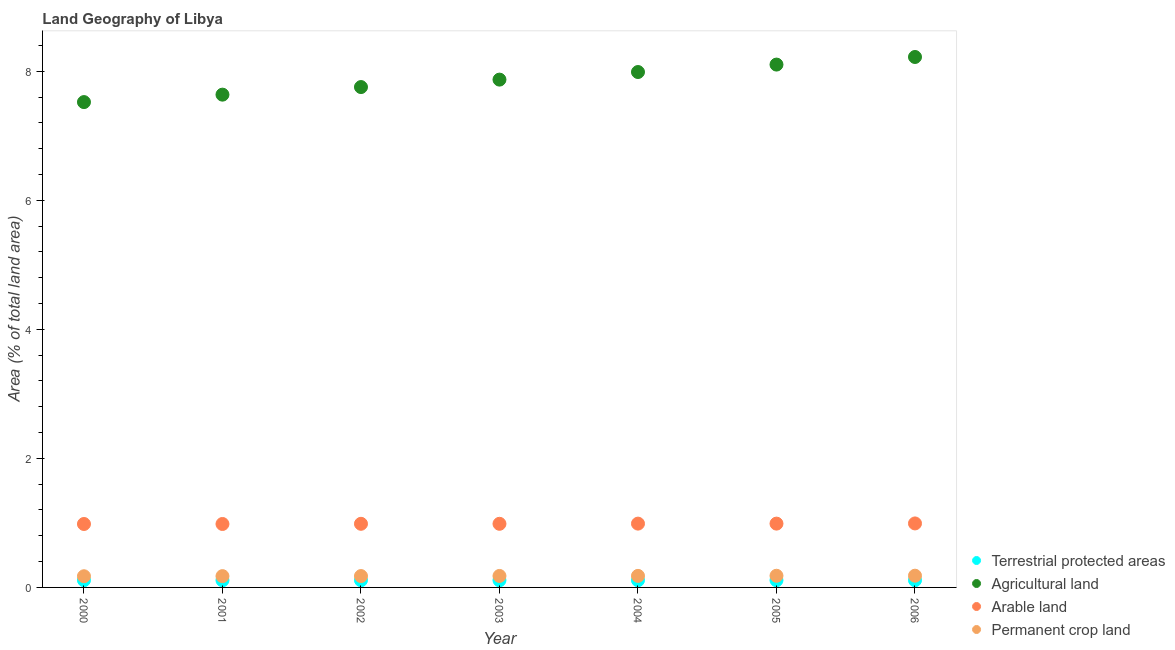What is the percentage of area under permanent crop land in 2001?
Your answer should be very brief. 0.18. Across all years, what is the maximum percentage of land under terrestrial protection?
Provide a short and direct response. 0.11. Across all years, what is the minimum percentage of area under arable land?
Your answer should be very brief. 0.98. In which year was the percentage of area under permanent crop land maximum?
Offer a very short reply. 2006. What is the total percentage of area under permanent crop land in the graph?
Provide a succinct answer. 1.24. What is the difference between the percentage of area under arable land in 2001 and that in 2003?
Your answer should be compact. -0. What is the difference between the percentage of area under permanent crop land in 2003 and the percentage of area under arable land in 2006?
Your answer should be compact. -0.81. What is the average percentage of area under arable land per year?
Your answer should be very brief. 0.99. In the year 2000, what is the difference between the percentage of area under agricultural land and percentage of area under permanent crop land?
Offer a terse response. 7.35. What is the ratio of the percentage of area under permanent crop land in 2001 to that in 2002?
Your response must be concise. 0.99. What is the difference between the highest and the second highest percentage of area under permanent crop land?
Give a very brief answer. 0. What is the difference between the highest and the lowest percentage of area under arable land?
Give a very brief answer. 0.01. In how many years, is the percentage of area under permanent crop land greater than the average percentage of area under permanent crop land taken over all years?
Your answer should be compact. 4. Is the sum of the percentage of area under permanent crop land in 2003 and 2006 greater than the maximum percentage of land under terrestrial protection across all years?
Your response must be concise. Yes. Does the percentage of area under arable land monotonically increase over the years?
Offer a terse response. No. Is the percentage of area under arable land strictly greater than the percentage of area under permanent crop land over the years?
Offer a terse response. Yes. Is the percentage of area under agricultural land strictly less than the percentage of land under terrestrial protection over the years?
Keep it short and to the point. No. How many dotlines are there?
Give a very brief answer. 4. Does the graph contain any zero values?
Give a very brief answer. No. Where does the legend appear in the graph?
Provide a short and direct response. Bottom right. How many legend labels are there?
Provide a succinct answer. 4. What is the title of the graph?
Ensure brevity in your answer.  Land Geography of Libya. Does "United States" appear as one of the legend labels in the graph?
Your answer should be compact. No. What is the label or title of the X-axis?
Make the answer very short. Year. What is the label or title of the Y-axis?
Offer a very short reply. Area (% of total land area). What is the Area (% of total land area) in Terrestrial protected areas in 2000?
Ensure brevity in your answer.  0.11. What is the Area (% of total land area) in Agricultural land in 2000?
Offer a very short reply. 7.52. What is the Area (% of total land area) in Arable land in 2000?
Keep it short and to the point. 0.98. What is the Area (% of total land area) of Permanent crop land in 2000?
Offer a very short reply. 0.17. What is the Area (% of total land area) of Terrestrial protected areas in 2001?
Give a very brief answer. 0.11. What is the Area (% of total land area) of Agricultural land in 2001?
Your answer should be very brief. 7.64. What is the Area (% of total land area) of Arable land in 2001?
Your response must be concise. 0.98. What is the Area (% of total land area) of Permanent crop land in 2001?
Provide a short and direct response. 0.18. What is the Area (% of total land area) in Terrestrial protected areas in 2002?
Provide a short and direct response. 0.11. What is the Area (% of total land area) in Agricultural land in 2002?
Your answer should be compact. 7.75. What is the Area (% of total land area) of Arable land in 2002?
Keep it short and to the point. 0.99. What is the Area (% of total land area) of Permanent crop land in 2002?
Provide a succinct answer. 0.18. What is the Area (% of total land area) in Terrestrial protected areas in 2003?
Keep it short and to the point. 0.11. What is the Area (% of total land area) of Agricultural land in 2003?
Make the answer very short. 7.87. What is the Area (% of total land area) in Arable land in 2003?
Provide a short and direct response. 0.99. What is the Area (% of total land area) in Permanent crop land in 2003?
Offer a very short reply. 0.18. What is the Area (% of total land area) of Terrestrial protected areas in 2004?
Ensure brevity in your answer.  0.11. What is the Area (% of total land area) of Agricultural land in 2004?
Ensure brevity in your answer.  7.99. What is the Area (% of total land area) in Arable land in 2004?
Provide a succinct answer. 0.99. What is the Area (% of total land area) in Permanent crop land in 2004?
Provide a short and direct response. 0.18. What is the Area (% of total land area) of Terrestrial protected areas in 2005?
Offer a very short reply. 0.11. What is the Area (% of total land area) in Agricultural land in 2005?
Provide a succinct answer. 8.1. What is the Area (% of total land area) of Arable land in 2005?
Your answer should be compact. 0.99. What is the Area (% of total land area) of Permanent crop land in 2005?
Offer a very short reply. 0.18. What is the Area (% of total land area) of Terrestrial protected areas in 2006?
Your answer should be very brief. 0.11. What is the Area (% of total land area) in Agricultural land in 2006?
Make the answer very short. 8.22. What is the Area (% of total land area) of Arable land in 2006?
Provide a short and direct response. 0.99. What is the Area (% of total land area) of Permanent crop land in 2006?
Keep it short and to the point. 0.18. Across all years, what is the maximum Area (% of total land area) of Terrestrial protected areas?
Your response must be concise. 0.11. Across all years, what is the maximum Area (% of total land area) in Agricultural land?
Your response must be concise. 8.22. Across all years, what is the maximum Area (% of total land area) in Arable land?
Provide a succinct answer. 0.99. Across all years, what is the maximum Area (% of total land area) of Permanent crop land?
Offer a very short reply. 0.18. Across all years, what is the minimum Area (% of total land area) of Terrestrial protected areas?
Your answer should be compact. 0.11. Across all years, what is the minimum Area (% of total land area) of Agricultural land?
Provide a succinct answer. 7.52. Across all years, what is the minimum Area (% of total land area) in Arable land?
Keep it short and to the point. 0.98. Across all years, what is the minimum Area (% of total land area) in Permanent crop land?
Offer a terse response. 0.17. What is the total Area (% of total land area) of Terrestrial protected areas in the graph?
Ensure brevity in your answer.  0.78. What is the total Area (% of total land area) of Agricultural land in the graph?
Your answer should be compact. 55.1. What is the total Area (% of total land area) in Arable land in the graph?
Offer a terse response. 6.91. What is the total Area (% of total land area) of Permanent crop land in the graph?
Provide a short and direct response. 1.24. What is the difference between the Area (% of total land area) in Terrestrial protected areas in 2000 and that in 2001?
Make the answer very short. 0. What is the difference between the Area (% of total land area) of Agricultural land in 2000 and that in 2001?
Keep it short and to the point. -0.12. What is the difference between the Area (% of total land area) of Permanent crop land in 2000 and that in 2001?
Your answer should be very brief. -0. What is the difference between the Area (% of total land area) of Terrestrial protected areas in 2000 and that in 2002?
Your answer should be very brief. 0. What is the difference between the Area (% of total land area) of Agricultural land in 2000 and that in 2002?
Keep it short and to the point. -0.23. What is the difference between the Area (% of total land area) of Arable land in 2000 and that in 2002?
Provide a succinct answer. -0. What is the difference between the Area (% of total land area) in Permanent crop land in 2000 and that in 2002?
Your answer should be very brief. -0. What is the difference between the Area (% of total land area) in Agricultural land in 2000 and that in 2003?
Your answer should be compact. -0.35. What is the difference between the Area (% of total land area) of Arable land in 2000 and that in 2003?
Give a very brief answer. -0. What is the difference between the Area (% of total land area) of Permanent crop land in 2000 and that in 2003?
Offer a very short reply. -0. What is the difference between the Area (% of total land area) of Agricultural land in 2000 and that in 2004?
Offer a very short reply. -0.47. What is the difference between the Area (% of total land area) of Arable land in 2000 and that in 2004?
Provide a succinct answer. -0.01. What is the difference between the Area (% of total land area) of Permanent crop land in 2000 and that in 2004?
Keep it short and to the point. -0.01. What is the difference between the Area (% of total land area) of Terrestrial protected areas in 2000 and that in 2005?
Keep it short and to the point. 0. What is the difference between the Area (% of total land area) of Agricultural land in 2000 and that in 2005?
Your response must be concise. -0.58. What is the difference between the Area (% of total land area) in Arable land in 2000 and that in 2005?
Your response must be concise. -0.01. What is the difference between the Area (% of total land area) in Permanent crop land in 2000 and that in 2005?
Offer a very short reply. -0.01. What is the difference between the Area (% of total land area) of Terrestrial protected areas in 2000 and that in 2006?
Your answer should be very brief. 0. What is the difference between the Area (% of total land area) in Agricultural land in 2000 and that in 2006?
Provide a succinct answer. -0.7. What is the difference between the Area (% of total land area) of Arable land in 2000 and that in 2006?
Your response must be concise. -0.01. What is the difference between the Area (% of total land area) of Permanent crop land in 2000 and that in 2006?
Your answer should be very brief. -0.01. What is the difference between the Area (% of total land area) of Terrestrial protected areas in 2001 and that in 2002?
Keep it short and to the point. -0. What is the difference between the Area (% of total land area) of Agricultural land in 2001 and that in 2002?
Offer a very short reply. -0.12. What is the difference between the Area (% of total land area) of Arable land in 2001 and that in 2002?
Your answer should be compact. -0. What is the difference between the Area (% of total land area) of Permanent crop land in 2001 and that in 2002?
Offer a very short reply. -0. What is the difference between the Area (% of total land area) in Terrestrial protected areas in 2001 and that in 2003?
Ensure brevity in your answer.  -0. What is the difference between the Area (% of total land area) of Agricultural land in 2001 and that in 2003?
Your answer should be very brief. -0.23. What is the difference between the Area (% of total land area) in Arable land in 2001 and that in 2003?
Keep it short and to the point. -0. What is the difference between the Area (% of total land area) of Permanent crop land in 2001 and that in 2003?
Your answer should be compact. -0. What is the difference between the Area (% of total land area) in Terrestrial protected areas in 2001 and that in 2004?
Provide a succinct answer. -0. What is the difference between the Area (% of total land area) of Agricultural land in 2001 and that in 2004?
Provide a short and direct response. -0.35. What is the difference between the Area (% of total land area) of Arable land in 2001 and that in 2004?
Ensure brevity in your answer.  -0.01. What is the difference between the Area (% of total land area) of Permanent crop land in 2001 and that in 2004?
Keep it short and to the point. -0. What is the difference between the Area (% of total land area) in Terrestrial protected areas in 2001 and that in 2005?
Keep it short and to the point. -0. What is the difference between the Area (% of total land area) in Agricultural land in 2001 and that in 2005?
Ensure brevity in your answer.  -0.47. What is the difference between the Area (% of total land area) of Arable land in 2001 and that in 2005?
Offer a very short reply. -0.01. What is the difference between the Area (% of total land area) of Permanent crop land in 2001 and that in 2005?
Your response must be concise. -0.01. What is the difference between the Area (% of total land area) in Terrestrial protected areas in 2001 and that in 2006?
Ensure brevity in your answer.  -0. What is the difference between the Area (% of total land area) of Agricultural land in 2001 and that in 2006?
Offer a terse response. -0.58. What is the difference between the Area (% of total land area) in Arable land in 2001 and that in 2006?
Offer a terse response. -0.01. What is the difference between the Area (% of total land area) of Permanent crop land in 2001 and that in 2006?
Make the answer very short. -0.01. What is the difference between the Area (% of total land area) in Terrestrial protected areas in 2002 and that in 2003?
Offer a terse response. 0. What is the difference between the Area (% of total land area) of Agricultural land in 2002 and that in 2003?
Provide a short and direct response. -0.12. What is the difference between the Area (% of total land area) of Arable land in 2002 and that in 2003?
Provide a short and direct response. 0. What is the difference between the Area (% of total land area) of Permanent crop land in 2002 and that in 2003?
Ensure brevity in your answer.  -0. What is the difference between the Area (% of total land area) in Terrestrial protected areas in 2002 and that in 2004?
Ensure brevity in your answer.  0. What is the difference between the Area (% of total land area) in Agricultural land in 2002 and that in 2004?
Offer a terse response. -0.23. What is the difference between the Area (% of total land area) in Arable land in 2002 and that in 2004?
Provide a succinct answer. -0. What is the difference between the Area (% of total land area) of Permanent crop land in 2002 and that in 2004?
Ensure brevity in your answer.  -0. What is the difference between the Area (% of total land area) in Agricultural land in 2002 and that in 2005?
Provide a short and direct response. -0.35. What is the difference between the Area (% of total land area) of Arable land in 2002 and that in 2005?
Offer a very short reply. -0. What is the difference between the Area (% of total land area) of Permanent crop land in 2002 and that in 2005?
Provide a succinct answer. -0. What is the difference between the Area (% of total land area) in Agricultural land in 2002 and that in 2006?
Your answer should be compact. -0.47. What is the difference between the Area (% of total land area) of Arable land in 2002 and that in 2006?
Keep it short and to the point. -0.01. What is the difference between the Area (% of total land area) in Permanent crop land in 2002 and that in 2006?
Your answer should be very brief. -0.01. What is the difference between the Area (% of total land area) of Terrestrial protected areas in 2003 and that in 2004?
Your answer should be very brief. 0. What is the difference between the Area (% of total land area) in Agricultural land in 2003 and that in 2004?
Make the answer very short. -0.12. What is the difference between the Area (% of total land area) in Arable land in 2003 and that in 2004?
Ensure brevity in your answer.  -0. What is the difference between the Area (% of total land area) in Permanent crop land in 2003 and that in 2004?
Ensure brevity in your answer.  -0. What is the difference between the Area (% of total land area) in Agricultural land in 2003 and that in 2005?
Provide a short and direct response. -0.23. What is the difference between the Area (% of total land area) in Arable land in 2003 and that in 2005?
Ensure brevity in your answer.  -0. What is the difference between the Area (% of total land area) in Permanent crop land in 2003 and that in 2005?
Offer a very short reply. -0. What is the difference between the Area (% of total land area) in Terrestrial protected areas in 2003 and that in 2006?
Offer a very short reply. 0. What is the difference between the Area (% of total land area) of Agricultural land in 2003 and that in 2006?
Provide a short and direct response. -0.35. What is the difference between the Area (% of total land area) of Arable land in 2003 and that in 2006?
Provide a short and direct response. -0.01. What is the difference between the Area (% of total land area) of Permanent crop land in 2003 and that in 2006?
Offer a very short reply. -0. What is the difference between the Area (% of total land area) in Terrestrial protected areas in 2004 and that in 2005?
Provide a succinct answer. 0. What is the difference between the Area (% of total land area) of Agricultural land in 2004 and that in 2005?
Provide a short and direct response. -0.12. What is the difference between the Area (% of total land area) in Permanent crop land in 2004 and that in 2005?
Provide a short and direct response. -0. What is the difference between the Area (% of total land area) in Terrestrial protected areas in 2004 and that in 2006?
Offer a very short reply. 0. What is the difference between the Area (% of total land area) in Agricultural land in 2004 and that in 2006?
Keep it short and to the point. -0.23. What is the difference between the Area (% of total land area) of Arable land in 2004 and that in 2006?
Keep it short and to the point. -0. What is the difference between the Area (% of total land area) in Permanent crop land in 2004 and that in 2006?
Provide a succinct answer. -0. What is the difference between the Area (% of total land area) of Terrestrial protected areas in 2005 and that in 2006?
Give a very brief answer. 0. What is the difference between the Area (% of total land area) of Agricultural land in 2005 and that in 2006?
Keep it short and to the point. -0.12. What is the difference between the Area (% of total land area) of Arable land in 2005 and that in 2006?
Your response must be concise. -0. What is the difference between the Area (% of total land area) in Permanent crop land in 2005 and that in 2006?
Your answer should be compact. -0. What is the difference between the Area (% of total land area) in Terrestrial protected areas in 2000 and the Area (% of total land area) in Agricultural land in 2001?
Your response must be concise. -7.53. What is the difference between the Area (% of total land area) in Terrestrial protected areas in 2000 and the Area (% of total land area) in Arable land in 2001?
Offer a very short reply. -0.87. What is the difference between the Area (% of total land area) of Terrestrial protected areas in 2000 and the Area (% of total land area) of Permanent crop land in 2001?
Provide a short and direct response. -0.06. What is the difference between the Area (% of total land area) in Agricultural land in 2000 and the Area (% of total land area) in Arable land in 2001?
Your answer should be compact. 6.54. What is the difference between the Area (% of total land area) of Agricultural land in 2000 and the Area (% of total land area) of Permanent crop land in 2001?
Provide a short and direct response. 7.35. What is the difference between the Area (% of total land area) of Arable land in 2000 and the Area (% of total land area) of Permanent crop land in 2001?
Offer a terse response. 0.81. What is the difference between the Area (% of total land area) in Terrestrial protected areas in 2000 and the Area (% of total land area) in Agricultural land in 2002?
Give a very brief answer. -7.64. What is the difference between the Area (% of total land area) in Terrestrial protected areas in 2000 and the Area (% of total land area) in Arable land in 2002?
Provide a short and direct response. -0.87. What is the difference between the Area (% of total land area) of Terrestrial protected areas in 2000 and the Area (% of total land area) of Permanent crop land in 2002?
Give a very brief answer. -0.06. What is the difference between the Area (% of total land area) of Agricultural land in 2000 and the Area (% of total land area) of Arable land in 2002?
Your answer should be compact. 6.54. What is the difference between the Area (% of total land area) of Agricultural land in 2000 and the Area (% of total land area) of Permanent crop land in 2002?
Your response must be concise. 7.35. What is the difference between the Area (% of total land area) in Arable land in 2000 and the Area (% of total land area) in Permanent crop land in 2002?
Keep it short and to the point. 0.81. What is the difference between the Area (% of total land area) of Terrestrial protected areas in 2000 and the Area (% of total land area) of Agricultural land in 2003?
Make the answer very short. -7.76. What is the difference between the Area (% of total land area) of Terrestrial protected areas in 2000 and the Area (% of total land area) of Arable land in 2003?
Offer a very short reply. -0.87. What is the difference between the Area (% of total land area) of Terrestrial protected areas in 2000 and the Area (% of total land area) of Permanent crop land in 2003?
Ensure brevity in your answer.  -0.07. What is the difference between the Area (% of total land area) of Agricultural land in 2000 and the Area (% of total land area) of Arable land in 2003?
Make the answer very short. 6.54. What is the difference between the Area (% of total land area) in Agricultural land in 2000 and the Area (% of total land area) in Permanent crop land in 2003?
Offer a very short reply. 7.34. What is the difference between the Area (% of total land area) in Arable land in 2000 and the Area (% of total land area) in Permanent crop land in 2003?
Keep it short and to the point. 0.81. What is the difference between the Area (% of total land area) in Terrestrial protected areas in 2000 and the Area (% of total land area) in Agricultural land in 2004?
Give a very brief answer. -7.88. What is the difference between the Area (% of total land area) in Terrestrial protected areas in 2000 and the Area (% of total land area) in Arable land in 2004?
Your answer should be very brief. -0.88. What is the difference between the Area (% of total land area) in Terrestrial protected areas in 2000 and the Area (% of total land area) in Permanent crop land in 2004?
Offer a very short reply. -0.07. What is the difference between the Area (% of total land area) in Agricultural land in 2000 and the Area (% of total land area) in Arable land in 2004?
Ensure brevity in your answer.  6.53. What is the difference between the Area (% of total land area) of Agricultural land in 2000 and the Area (% of total land area) of Permanent crop land in 2004?
Offer a very short reply. 7.34. What is the difference between the Area (% of total land area) in Arable land in 2000 and the Area (% of total land area) in Permanent crop land in 2004?
Your answer should be compact. 0.8. What is the difference between the Area (% of total land area) of Terrestrial protected areas in 2000 and the Area (% of total land area) of Agricultural land in 2005?
Keep it short and to the point. -7.99. What is the difference between the Area (% of total land area) of Terrestrial protected areas in 2000 and the Area (% of total land area) of Arable land in 2005?
Make the answer very short. -0.88. What is the difference between the Area (% of total land area) in Terrestrial protected areas in 2000 and the Area (% of total land area) in Permanent crop land in 2005?
Keep it short and to the point. -0.07. What is the difference between the Area (% of total land area) in Agricultural land in 2000 and the Area (% of total land area) in Arable land in 2005?
Your response must be concise. 6.53. What is the difference between the Area (% of total land area) of Agricultural land in 2000 and the Area (% of total land area) of Permanent crop land in 2005?
Your answer should be very brief. 7.34. What is the difference between the Area (% of total land area) of Arable land in 2000 and the Area (% of total land area) of Permanent crop land in 2005?
Ensure brevity in your answer.  0.8. What is the difference between the Area (% of total land area) in Terrestrial protected areas in 2000 and the Area (% of total land area) in Agricultural land in 2006?
Make the answer very short. -8.11. What is the difference between the Area (% of total land area) in Terrestrial protected areas in 2000 and the Area (% of total land area) in Arable land in 2006?
Ensure brevity in your answer.  -0.88. What is the difference between the Area (% of total land area) in Terrestrial protected areas in 2000 and the Area (% of total land area) in Permanent crop land in 2006?
Your answer should be very brief. -0.07. What is the difference between the Area (% of total land area) of Agricultural land in 2000 and the Area (% of total land area) of Arable land in 2006?
Provide a succinct answer. 6.53. What is the difference between the Area (% of total land area) in Agricultural land in 2000 and the Area (% of total land area) in Permanent crop land in 2006?
Your answer should be compact. 7.34. What is the difference between the Area (% of total land area) in Arable land in 2000 and the Area (% of total land area) in Permanent crop land in 2006?
Offer a very short reply. 0.8. What is the difference between the Area (% of total land area) in Terrestrial protected areas in 2001 and the Area (% of total land area) in Agricultural land in 2002?
Ensure brevity in your answer.  -7.64. What is the difference between the Area (% of total land area) in Terrestrial protected areas in 2001 and the Area (% of total land area) in Arable land in 2002?
Offer a very short reply. -0.88. What is the difference between the Area (% of total land area) in Terrestrial protected areas in 2001 and the Area (% of total land area) in Permanent crop land in 2002?
Make the answer very short. -0.07. What is the difference between the Area (% of total land area) in Agricultural land in 2001 and the Area (% of total land area) in Arable land in 2002?
Keep it short and to the point. 6.65. What is the difference between the Area (% of total land area) in Agricultural land in 2001 and the Area (% of total land area) in Permanent crop land in 2002?
Your answer should be compact. 7.46. What is the difference between the Area (% of total land area) of Arable land in 2001 and the Area (% of total land area) of Permanent crop land in 2002?
Offer a very short reply. 0.81. What is the difference between the Area (% of total land area) in Terrestrial protected areas in 2001 and the Area (% of total land area) in Agricultural land in 2003?
Keep it short and to the point. -7.76. What is the difference between the Area (% of total land area) in Terrestrial protected areas in 2001 and the Area (% of total land area) in Arable land in 2003?
Your answer should be compact. -0.88. What is the difference between the Area (% of total land area) of Terrestrial protected areas in 2001 and the Area (% of total land area) of Permanent crop land in 2003?
Give a very brief answer. -0.07. What is the difference between the Area (% of total land area) in Agricultural land in 2001 and the Area (% of total land area) in Arable land in 2003?
Your response must be concise. 6.65. What is the difference between the Area (% of total land area) of Agricultural land in 2001 and the Area (% of total land area) of Permanent crop land in 2003?
Your answer should be very brief. 7.46. What is the difference between the Area (% of total land area) in Arable land in 2001 and the Area (% of total land area) in Permanent crop land in 2003?
Make the answer very short. 0.81. What is the difference between the Area (% of total land area) of Terrestrial protected areas in 2001 and the Area (% of total land area) of Agricultural land in 2004?
Your answer should be very brief. -7.88. What is the difference between the Area (% of total land area) of Terrestrial protected areas in 2001 and the Area (% of total land area) of Arable land in 2004?
Provide a short and direct response. -0.88. What is the difference between the Area (% of total land area) of Terrestrial protected areas in 2001 and the Area (% of total land area) of Permanent crop land in 2004?
Provide a short and direct response. -0.07. What is the difference between the Area (% of total land area) of Agricultural land in 2001 and the Area (% of total land area) of Arable land in 2004?
Make the answer very short. 6.65. What is the difference between the Area (% of total land area) in Agricultural land in 2001 and the Area (% of total land area) in Permanent crop land in 2004?
Make the answer very short. 7.46. What is the difference between the Area (% of total land area) in Arable land in 2001 and the Area (% of total land area) in Permanent crop land in 2004?
Give a very brief answer. 0.8. What is the difference between the Area (% of total land area) of Terrestrial protected areas in 2001 and the Area (% of total land area) of Agricultural land in 2005?
Offer a terse response. -7.99. What is the difference between the Area (% of total land area) in Terrestrial protected areas in 2001 and the Area (% of total land area) in Arable land in 2005?
Your answer should be very brief. -0.88. What is the difference between the Area (% of total land area) in Terrestrial protected areas in 2001 and the Area (% of total land area) in Permanent crop land in 2005?
Provide a succinct answer. -0.07. What is the difference between the Area (% of total land area) in Agricultural land in 2001 and the Area (% of total land area) in Arable land in 2005?
Your answer should be compact. 6.65. What is the difference between the Area (% of total land area) in Agricultural land in 2001 and the Area (% of total land area) in Permanent crop land in 2005?
Your answer should be very brief. 7.46. What is the difference between the Area (% of total land area) of Arable land in 2001 and the Area (% of total land area) of Permanent crop land in 2005?
Your response must be concise. 0.8. What is the difference between the Area (% of total land area) of Terrestrial protected areas in 2001 and the Area (% of total land area) of Agricultural land in 2006?
Your answer should be compact. -8.11. What is the difference between the Area (% of total land area) in Terrestrial protected areas in 2001 and the Area (% of total land area) in Arable land in 2006?
Offer a very short reply. -0.88. What is the difference between the Area (% of total land area) in Terrestrial protected areas in 2001 and the Area (% of total land area) in Permanent crop land in 2006?
Provide a succinct answer. -0.07. What is the difference between the Area (% of total land area) of Agricultural land in 2001 and the Area (% of total land area) of Arable land in 2006?
Offer a very short reply. 6.65. What is the difference between the Area (% of total land area) in Agricultural land in 2001 and the Area (% of total land area) in Permanent crop land in 2006?
Your answer should be compact. 7.46. What is the difference between the Area (% of total land area) in Arable land in 2001 and the Area (% of total land area) in Permanent crop land in 2006?
Make the answer very short. 0.8. What is the difference between the Area (% of total land area) of Terrestrial protected areas in 2002 and the Area (% of total land area) of Agricultural land in 2003?
Your answer should be very brief. -7.76. What is the difference between the Area (% of total land area) of Terrestrial protected areas in 2002 and the Area (% of total land area) of Arable land in 2003?
Your answer should be very brief. -0.87. What is the difference between the Area (% of total land area) of Terrestrial protected areas in 2002 and the Area (% of total land area) of Permanent crop land in 2003?
Your answer should be very brief. -0.07. What is the difference between the Area (% of total land area) in Agricultural land in 2002 and the Area (% of total land area) in Arable land in 2003?
Keep it short and to the point. 6.77. What is the difference between the Area (% of total land area) in Agricultural land in 2002 and the Area (% of total land area) in Permanent crop land in 2003?
Keep it short and to the point. 7.58. What is the difference between the Area (% of total land area) of Arable land in 2002 and the Area (% of total land area) of Permanent crop land in 2003?
Your answer should be very brief. 0.81. What is the difference between the Area (% of total land area) in Terrestrial protected areas in 2002 and the Area (% of total land area) in Agricultural land in 2004?
Ensure brevity in your answer.  -7.88. What is the difference between the Area (% of total land area) of Terrestrial protected areas in 2002 and the Area (% of total land area) of Arable land in 2004?
Ensure brevity in your answer.  -0.88. What is the difference between the Area (% of total land area) in Terrestrial protected areas in 2002 and the Area (% of total land area) in Permanent crop land in 2004?
Your answer should be compact. -0.07. What is the difference between the Area (% of total land area) of Agricultural land in 2002 and the Area (% of total land area) of Arable land in 2004?
Your answer should be compact. 6.77. What is the difference between the Area (% of total land area) of Agricultural land in 2002 and the Area (% of total land area) of Permanent crop land in 2004?
Make the answer very short. 7.58. What is the difference between the Area (% of total land area) in Arable land in 2002 and the Area (% of total land area) in Permanent crop land in 2004?
Your answer should be compact. 0.81. What is the difference between the Area (% of total land area) of Terrestrial protected areas in 2002 and the Area (% of total land area) of Agricultural land in 2005?
Keep it short and to the point. -7.99. What is the difference between the Area (% of total land area) of Terrestrial protected areas in 2002 and the Area (% of total land area) of Arable land in 2005?
Ensure brevity in your answer.  -0.88. What is the difference between the Area (% of total land area) in Terrestrial protected areas in 2002 and the Area (% of total land area) in Permanent crop land in 2005?
Make the answer very short. -0.07. What is the difference between the Area (% of total land area) of Agricultural land in 2002 and the Area (% of total land area) of Arable land in 2005?
Ensure brevity in your answer.  6.77. What is the difference between the Area (% of total land area) in Agricultural land in 2002 and the Area (% of total land area) in Permanent crop land in 2005?
Give a very brief answer. 7.57. What is the difference between the Area (% of total land area) in Arable land in 2002 and the Area (% of total land area) in Permanent crop land in 2005?
Provide a short and direct response. 0.81. What is the difference between the Area (% of total land area) in Terrestrial protected areas in 2002 and the Area (% of total land area) in Agricultural land in 2006?
Your response must be concise. -8.11. What is the difference between the Area (% of total land area) in Terrestrial protected areas in 2002 and the Area (% of total land area) in Arable land in 2006?
Keep it short and to the point. -0.88. What is the difference between the Area (% of total land area) in Terrestrial protected areas in 2002 and the Area (% of total land area) in Permanent crop land in 2006?
Your response must be concise. -0.07. What is the difference between the Area (% of total land area) in Agricultural land in 2002 and the Area (% of total land area) in Arable land in 2006?
Make the answer very short. 6.76. What is the difference between the Area (% of total land area) in Agricultural land in 2002 and the Area (% of total land area) in Permanent crop land in 2006?
Your answer should be compact. 7.57. What is the difference between the Area (% of total land area) of Arable land in 2002 and the Area (% of total land area) of Permanent crop land in 2006?
Keep it short and to the point. 0.8. What is the difference between the Area (% of total land area) of Terrestrial protected areas in 2003 and the Area (% of total land area) of Agricultural land in 2004?
Provide a short and direct response. -7.88. What is the difference between the Area (% of total land area) of Terrestrial protected areas in 2003 and the Area (% of total land area) of Arable land in 2004?
Give a very brief answer. -0.88. What is the difference between the Area (% of total land area) in Terrestrial protected areas in 2003 and the Area (% of total land area) in Permanent crop land in 2004?
Provide a short and direct response. -0.07. What is the difference between the Area (% of total land area) in Agricultural land in 2003 and the Area (% of total land area) in Arable land in 2004?
Keep it short and to the point. 6.88. What is the difference between the Area (% of total land area) in Agricultural land in 2003 and the Area (% of total land area) in Permanent crop land in 2004?
Offer a very short reply. 7.69. What is the difference between the Area (% of total land area) in Arable land in 2003 and the Area (% of total land area) in Permanent crop land in 2004?
Make the answer very short. 0.81. What is the difference between the Area (% of total land area) of Terrestrial protected areas in 2003 and the Area (% of total land area) of Agricultural land in 2005?
Offer a terse response. -7.99. What is the difference between the Area (% of total land area) in Terrestrial protected areas in 2003 and the Area (% of total land area) in Arable land in 2005?
Give a very brief answer. -0.88. What is the difference between the Area (% of total land area) of Terrestrial protected areas in 2003 and the Area (% of total land area) of Permanent crop land in 2005?
Your answer should be compact. -0.07. What is the difference between the Area (% of total land area) in Agricultural land in 2003 and the Area (% of total land area) in Arable land in 2005?
Your answer should be compact. 6.88. What is the difference between the Area (% of total land area) in Agricultural land in 2003 and the Area (% of total land area) in Permanent crop land in 2005?
Offer a very short reply. 7.69. What is the difference between the Area (% of total land area) in Arable land in 2003 and the Area (% of total land area) in Permanent crop land in 2005?
Offer a terse response. 0.81. What is the difference between the Area (% of total land area) in Terrestrial protected areas in 2003 and the Area (% of total land area) in Agricultural land in 2006?
Give a very brief answer. -8.11. What is the difference between the Area (% of total land area) of Terrestrial protected areas in 2003 and the Area (% of total land area) of Arable land in 2006?
Offer a terse response. -0.88. What is the difference between the Area (% of total land area) in Terrestrial protected areas in 2003 and the Area (% of total land area) in Permanent crop land in 2006?
Your response must be concise. -0.07. What is the difference between the Area (% of total land area) in Agricultural land in 2003 and the Area (% of total land area) in Arable land in 2006?
Offer a terse response. 6.88. What is the difference between the Area (% of total land area) in Agricultural land in 2003 and the Area (% of total land area) in Permanent crop land in 2006?
Your answer should be very brief. 7.69. What is the difference between the Area (% of total land area) in Arable land in 2003 and the Area (% of total land area) in Permanent crop land in 2006?
Make the answer very short. 0.8. What is the difference between the Area (% of total land area) in Terrestrial protected areas in 2004 and the Area (% of total land area) in Agricultural land in 2005?
Your response must be concise. -7.99. What is the difference between the Area (% of total land area) of Terrestrial protected areas in 2004 and the Area (% of total land area) of Arable land in 2005?
Your answer should be compact. -0.88. What is the difference between the Area (% of total land area) of Terrestrial protected areas in 2004 and the Area (% of total land area) of Permanent crop land in 2005?
Give a very brief answer. -0.07. What is the difference between the Area (% of total land area) in Agricultural land in 2004 and the Area (% of total land area) in Arable land in 2005?
Keep it short and to the point. 7. What is the difference between the Area (% of total land area) of Agricultural land in 2004 and the Area (% of total land area) of Permanent crop land in 2005?
Provide a short and direct response. 7.81. What is the difference between the Area (% of total land area) of Arable land in 2004 and the Area (% of total land area) of Permanent crop land in 2005?
Your response must be concise. 0.81. What is the difference between the Area (% of total land area) in Terrestrial protected areas in 2004 and the Area (% of total land area) in Agricultural land in 2006?
Your answer should be very brief. -8.11. What is the difference between the Area (% of total land area) of Terrestrial protected areas in 2004 and the Area (% of total land area) of Arable land in 2006?
Your answer should be compact. -0.88. What is the difference between the Area (% of total land area) in Terrestrial protected areas in 2004 and the Area (% of total land area) in Permanent crop land in 2006?
Your answer should be compact. -0.07. What is the difference between the Area (% of total land area) of Agricultural land in 2004 and the Area (% of total land area) of Arable land in 2006?
Provide a short and direct response. 7. What is the difference between the Area (% of total land area) in Agricultural land in 2004 and the Area (% of total land area) in Permanent crop land in 2006?
Offer a very short reply. 7.81. What is the difference between the Area (% of total land area) in Arable land in 2004 and the Area (% of total land area) in Permanent crop land in 2006?
Provide a succinct answer. 0.81. What is the difference between the Area (% of total land area) of Terrestrial protected areas in 2005 and the Area (% of total land area) of Agricultural land in 2006?
Provide a short and direct response. -8.11. What is the difference between the Area (% of total land area) of Terrestrial protected areas in 2005 and the Area (% of total land area) of Arable land in 2006?
Offer a very short reply. -0.88. What is the difference between the Area (% of total land area) of Terrestrial protected areas in 2005 and the Area (% of total land area) of Permanent crop land in 2006?
Offer a very short reply. -0.07. What is the difference between the Area (% of total land area) of Agricultural land in 2005 and the Area (% of total land area) of Arable land in 2006?
Your answer should be very brief. 7.11. What is the difference between the Area (% of total land area) of Agricultural land in 2005 and the Area (% of total land area) of Permanent crop land in 2006?
Offer a terse response. 7.92. What is the difference between the Area (% of total land area) of Arable land in 2005 and the Area (% of total land area) of Permanent crop land in 2006?
Ensure brevity in your answer.  0.81. What is the average Area (% of total land area) of Terrestrial protected areas per year?
Your answer should be very brief. 0.11. What is the average Area (% of total land area) of Agricultural land per year?
Ensure brevity in your answer.  7.87. What is the average Area (% of total land area) of Arable land per year?
Ensure brevity in your answer.  0.99. What is the average Area (% of total land area) of Permanent crop land per year?
Your answer should be very brief. 0.18. In the year 2000, what is the difference between the Area (% of total land area) of Terrestrial protected areas and Area (% of total land area) of Agricultural land?
Your response must be concise. -7.41. In the year 2000, what is the difference between the Area (% of total land area) of Terrestrial protected areas and Area (% of total land area) of Arable land?
Ensure brevity in your answer.  -0.87. In the year 2000, what is the difference between the Area (% of total land area) in Terrestrial protected areas and Area (% of total land area) in Permanent crop land?
Offer a terse response. -0.06. In the year 2000, what is the difference between the Area (% of total land area) in Agricultural land and Area (% of total land area) in Arable land?
Keep it short and to the point. 6.54. In the year 2000, what is the difference between the Area (% of total land area) of Agricultural land and Area (% of total land area) of Permanent crop land?
Provide a succinct answer. 7.35. In the year 2000, what is the difference between the Area (% of total land area) of Arable land and Area (% of total land area) of Permanent crop land?
Ensure brevity in your answer.  0.81. In the year 2001, what is the difference between the Area (% of total land area) in Terrestrial protected areas and Area (% of total land area) in Agricultural land?
Keep it short and to the point. -7.53. In the year 2001, what is the difference between the Area (% of total land area) in Terrestrial protected areas and Area (% of total land area) in Arable land?
Your answer should be compact. -0.87. In the year 2001, what is the difference between the Area (% of total land area) of Terrestrial protected areas and Area (% of total land area) of Permanent crop land?
Provide a short and direct response. -0.06. In the year 2001, what is the difference between the Area (% of total land area) in Agricultural land and Area (% of total land area) in Arable land?
Keep it short and to the point. 6.65. In the year 2001, what is the difference between the Area (% of total land area) of Agricultural land and Area (% of total land area) of Permanent crop land?
Your answer should be very brief. 7.46. In the year 2001, what is the difference between the Area (% of total land area) in Arable land and Area (% of total land area) in Permanent crop land?
Your response must be concise. 0.81. In the year 2002, what is the difference between the Area (% of total land area) in Terrestrial protected areas and Area (% of total land area) in Agricultural land?
Make the answer very short. -7.64. In the year 2002, what is the difference between the Area (% of total land area) of Terrestrial protected areas and Area (% of total land area) of Arable land?
Ensure brevity in your answer.  -0.87. In the year 2002, what is the difference between the Area (% of total land area) in Terrestrial protected areas and Area (% of total land area) in Permanent crop land?
Your response must be concise. -0.07. In the year 2002, what is the difference between the Area (% of total land area) of Agricultural land and Area (% of total land area) of Arable land?
Provide a short and direct response. 6.77. In the year 2002, what is the difference between the Area (% of total land area) in Agricultural land and Area (% of total land area) in Permanent crop land?
Your answer should be very brief. 7.58. In the year 2002, what is the difference between the Area (% of total land area) of Arable land and Area (% of total land area) of Permanent crop land?
Your answer should be very brief. 0.81. In the year 2003, what is the difference between the Area (% of total land area) of Terrestrial protected areas and Area (% of total land area) of Agricultural land?
Offer a terse response. -7.76. In the year 2003, what is the difference between the Area (% of total land area) of Terrestrial protected areas and Area (% of total land area) of Arable land?
Your response must be concise. -0.87. In the year 2003, what is the difference between the Area (% of total land area) in Terrestrial protected areas and Area (% of total land area) in Permanent crop land?
Your answer should be very brief. -0.07. In the year 2003, what is the difference between the Area (% of total land area) of Agricultural land and Area (% of total land area) of Arable land?
Provide a succinct answer. 6.88. In the year 2003, what is the difference between the Area (% of total land area) of Agricultural land and Area (% of total land area) of Permanent crop land?
Your response must be concise. 7.69. In the year 2003, what is the difference between the Area (% of total land area) of Arable land and Area (% of total land area) of Permanent crop land?
Your answer should be very brief. 0.81. In the year 2004, what is the difference between the Area (% of total land area) of Terrestrial protected areas and Area (% of total land area) of Agricultural land?
Keep it short and to the point. -7.88. In the year 2004, what is the difference between the Area (% of total land area) in Terrestrial protected areas and Area (% of total land area) in Arable land?
Make the answer very short. -0.88. In the year 2004, what is the difference between the Area (% of total land area) in Terrestrial protected areas and Area (% of total land area) in Permanent crop land?
Your answer should be compact. -0.07. In the year 2004, what is the difference between the Area (% of total land area) in Agricultural land and Area (% of total land area) in Arable land?
Your answer should be very brief. 7. In the year 2004, what is the difference between the Area (% of total land area) of Agricultural land and Area (% of total land area) of Permanent crop land?
Offer a very short reply. 7.81. In the year 2004, what is the difference between the Area (% of total land area) in Arable land and Area (% of total land area) in Permanent crop land?
Offer a terse response. 0.81. In the year 2005, what is the difference between the Area (% of total land area) in Terrestrial protected areas and Area (% of total land area) in Agricultural land?
Provide a succinct answer. -7.99. In the year 2005, what is the difference between the Area (% of total land area) in Terrestrial protected areas and Area (% of total land area) in Arable land?
Provide a succinct answer. -0.88. In the year 2005, what is the difference between the Area (% of total land area) of Terrestrial protected areas and Area (% of total land area) of Permanent crop land?
Your answer should be compact. -0.07. In the year 2005, what is the difference between the Area (% of total land area) of Agricultural land and Area (% of total land area) of Arable land?
Ensure brevity in your answer.  7.11. In the year 2005, what is the difference between the Area (% of total land area) in Agricultural land and Area (% of total land area) in Permanent crop land?
Give a very brief answer. 7.92. In the year 2005, what is the difference between the Area (% of total land area) in Arable land and Area (% of total land area) in Permanent crop land?
Offer a very short reply. 0.81. In the year 2006, what is the difference between the Area (% of total land area) in Terrestrial protected areas and Area (% of total land area) in Agricultural land?
Your response must be concise. -8.11. In the year 2006, what is the difference between the Area (% of total land area) of Terrestrial protected areas and Area (% of total land area) of Arable land?
Your answer should be compact. -0.88. In the year 2006, what is the difference between the Area (% of total land area) in Terrestrial protected areas and Area (% of total land area) in Permanent crop land?
Give a very brief answer. -0.07. In the year 2006, what is the difference between the Area (% of total land area) of Agricultural land and Area (% of total land area) of Arable land?
Your response must be concise. 7.23. In the year 2006, what is the difference between the Area (% of total land area) in Agricultural land and Area (% of total land area) in Permanent crop land?
Offer a terse response. 8.04. In the year 2006, what is the difference between the Area (% of total land area) in Arable land and Area (% of total land area) in Permanent crop land?
Provide a succinct answer. 0.81. What is the ratio of the Area (% of total land area) of Terrestrial protected areas in 2000 to that in 2001?
Give a very brief answer. 1.01. What is the ratio of the Area (% of total land area) of Agricultural land in 2000 to that in 2001?
Your answer should be compact. 0.98. What is the ratio of the Area (% of total land area) of Arable land in 2000 to that in 2001?
Keep it short and to the point. 1. What is the ratio of the Area (% of total land area) of Permanent crop land in 2000 to that in 2001?
Offer a terse response. 0.99. What is the ratio of the Area (% of total land area) in Terrestrial protected areas in 2000 to that in 2002?
Offer a very short reply. 1. What is the ratio of the Area (% of total land area) of Permanent crop land in 2000 to that in 2002?
Your answer should be very brief. 0.98. What is the ratio of the Area (% of total land area) of Agricultural land in 2000 to that in 2003?
Provide a short and direct response. 0.96. What is the ratio of the Area (% of total land area) in Permanent crop land in 2000 to that in 2003?
Your answer should be compact. 0.97. What is the ratio of the Area (% of total land area) in Terrestrial protected areas in 2000 to that in 2004?
Your answer should be very brief. 1. What is the ratio of the Area (% of total land area) in Agricultural land in 2000 to that in 2004?
Keep it short and to the point. 0.94. What is the ratio of the Area (% of total land area) of Permanent crop land in 2000 to that in 2004?
Provide a succinct answer. 0.97. What is the ratio of the Area (% of total land area) in Terrestrial protected areas in 2000 to that in 2005?
Your response must be concise. 1. What is the ratio of the Area (% of total land area) of Agricultural land in 2000 to that in 2005?
Offer a terse response. 0.93. What is the ratio of the Area (% of total land area) in Arable land in 2000 to that in 2005?
Make the answer very short. 0.99. What is the ratio of the Area (% of total land area) in Permanent crop land in 2000 to that in 2005?
Keep it short and to the point. 0.96. What is the ratio of the Area (% of total land area) in Terrestrial protected areas in 2000 to that in 2006?
Offer a terse response. 1. What is the ratio of the Area (% of total land area) in Agricultural land in 2000 to that in 2006?
Make the answer very short. 0.92. What is the ratio of the Area (% of total land area) of Arable land in 2000 to that in 2006?
Offer a very short reply. 0.99. What is the ratio of the Area (% of total land area) in Permanent crop land in 2000 to that in 2006?
Your answer should be compact. 0.95. What is the ratio of the Area (% of total land area) in Agricultural land in 2001 to that in 2002?
Provide a succinct answer. 0.98. What is the ratio of the Area (% of total land area) in Agricultural land in 2001 to that in 2003?
Make the answer very short. 0.97. What is the ratio of the Area (% of total land area) in Arable land in 2001 to that in 2003?
Offer a terse response. 1. What is the ratio of the Area (% of total land area) of Permanent crop land in 2001 to that in 2003?
Keep it short and to the point. 0.98. What is the ratio of the Area (% of total land area) of Terrestrial protected areas in 2001 to that in 2004?
Provide a short and direct response. 1. What is the ratio of the Area (% of total land area) of Agricultural land in 2001 to that in 2004?
Keep it short and to the point. 0.96. What is the ratio of the Area (% of total land area) of Arable land in 2001 to that in 2004?
Your answer should be compact. 0.99. What is the ratio of the Area (% of total land area) in Permanent crop land in 2001 to that in 2004?
Ensure brevity in your answer.  0.98. What is the ratio of the Area (% of total land area) of Terrestrial protected areas in 2001 to that in 2005?
Keep it short and to the point. 1. What is the ratio of the Area (% of total land area) in Agricultural land in 2001 to that in 2005?
Provide a short and direct response. 0.94. What is the ratio of the Area (% of total land area) of Arable land in 2001 to that in 2005?
Your answer should be very brief. 0.99. What is the ratio of the Area (% of total land area) of Permanent crop land in 2001 to that in 2005?
Provide a short and direct response. 0.97. What is the ratio of the Area (% of total land area) in Agricultural land in 2001 to that in 2006?
Ensure brevity in your answer.  0.93. What is the ratio of the Area (% of total land area) in Permanent crop land in 2001 to that in 2006?
Ensure brevity in your answer.  0.96. What is the ratio of the Area (% of total land area) of Terrestrial protected areas in 2002 to that in 2003?
Provide a succinct answer. 1. What is the ratio of the Area (% of total land area) of Agricultural land in 2002 to that in 2003?
Offer a very short reply. 0.99. What is the ratio of the Area (% of total land area) of Arable land in 2002 to that in 2003?
Offer a terse response. 1. What is the ratio of the Area (% of total land area) in Permanent crop land in 2002 to that in 2003?
Offer a very short reply. 0.99. What is the ratio of the Area (% of total land area) of Agricultural land in 2002 to that in 2004?
Offer a very short reply. 0.97. What is the ratio of the Area (% of total land area) of Permanent crop land in 2002 to that in 2004?
Keep it short and to the point. 0.98. What is the ratio of the Area (% of total land area) of Arable land in 2002 to that in 2005?
Ensure brevity in your answer.  1. What is the ratio of the Area (% of total land area) in Permanent crop land in 2002 to that in 2005?
Keep it short and to the point. 0.97. What is the ratio of the Area (% of total land area) in Agricultural land in 2002 to that in 2006?
Make the answer very short. 0.94. What is the ratio of the Area (% of total land area) of Permanent crop land in 2002 to that in 2006?
Ensure brevity in your answer.  0.97. What is the ratio of the Area (% of total land area) in Terrestrial protected areas in 2003 to that in 2004?
Your answer should be very brief. 1. What is the ratio of the Area (% of total land area) in Arable land in 2003 to that in 2004?
Provide a short and direct response. 1. What is the ratio of the Area (% of total land area) of Agricultural land in 2003 to that in 2005?
Your response must be concise. 0.97. What is the ratio of the Area (% of total land area) in Permanent crop land in 2003 to that in 2005?
Provide a short and direct response. 0.98. What is the ratio of the Area (% of total land area) of Agricultural land in 2003 to that in 2006?
Ensure brevity in your answer.  0.96. What is the ratio of the Area (% of total land area) of Permanent crop land in 2003 to that in 2006?
Your answer should be compact. 0.98. What is the ratio of the Area (% of total land area) of Terrestrial protected areas in 2004 to that in 2005?
Give a very brief answer. 1. What is the ratio of the Area (% of total land area) of Agricultural land in 2004 to that in 2005?
Give a very brief answer. 0.99. What is the ratio of the Area (% of total land area) in Arable land in 2004 to that in 2005?
Ensure brevity in your answer.  1. What is the ratio of the Area (% of total land area) of Permanent crop land in 2004 to that in 2005?
Keep it short and to the point. 0.99. What is the ratio of the Area (% of total land area) of Agricultural land in 2004 to that in 2006?
Give a very brief answer. 0.97. What is the ratio of the Area (% of total land area) in Arable land in 2004 to that in 2006?
Make the answer very short. 1. What is the ratio of the Area (% of total land area) in Permanent crop land in 2004 to that in 2006?
Offer a terse response. 0.98. What is the ratio of the Area (% of total land area) in Terrestrial protected areas in 2005 to that in 2006?
Keep it short and to the point. 1. What is the ratio of the Area (% of total land area) in Agricultural land in 2005 to that in 2006?
Make the answer very short. 0.99. What is the difference between the highest and the second highest Area (% of total land area) of Agricultural land?
Offer a terse response. 0.12. What is the difference between the highest and the second highest Area (% of total land area) in Arable land?
Keep it short and to the point. 0. What is the difference between the highest and the second highest Area (% of total land area) in Permanent crop land?
Your answer should be compact. 0. What is the difference between the highest and the lowest Area (% of total land area) in Terrestrial protected areas?
Make the answer very short. 0. What is the difference between the highest and the lowest Area (% of total land area) of Agricultural land?
Ensure brevity in your answer.  0.7. What is the difference between the highest and the lowest Area (% of total land area) in Arable land?
Offer a terse response. 0.01. What is the difference between the highest and the lowest Area (% of total land area) of Permanent crop land?
Offer a terse response. 0.01. 